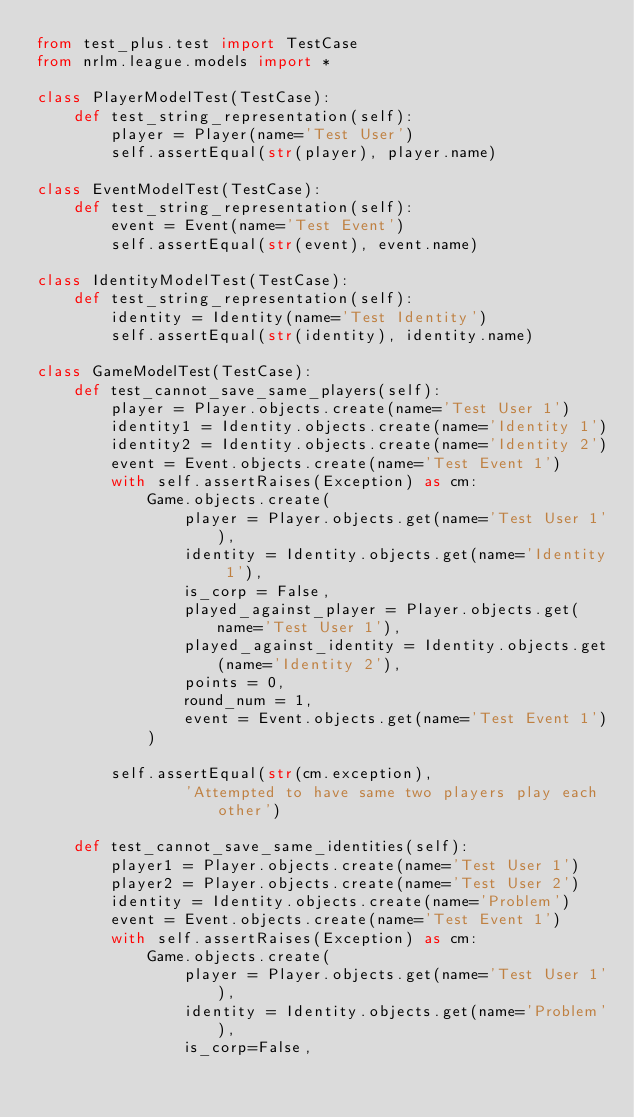Convert code to text. <code><loc_0><loc_0><loc_500><loc_500><_Python_>from test_plus.test import TestCase
from nrlm.league.models import *

class PlayerModelTest(TestCase):
    def test_string_representation(self):
        player = Player(name='Test User')
        self.assertEqual(str(player), player.name)

class EventModelTest(TestCase):
    def test_string_representation(self):
        event = Event(name='Test Event')
        self.assertEqual(str(event), event.name)

class IdentityModelTest(TestCase):
    def test_string_representation(self):
        identity = Identity(name='Test Identity')
        self.assertEqual(str(identity), identity.name)

class GameModelTest(TestCase):
    def test_cannot_save_same_players(self):
        player = Player.objects.create(name='Test User 1')
        identity1 = Identity.objects.create(name='Identity 1')
        identity2 = Identity.objects.create(name='Identity 2')
        event = Event.objects.create(name='Test Event 1')
        with self.assertRaises(Exception) as cm:
            Game.objects.create(
                player = Player.objects.get(name='Test User 1'),
                identity = Identity.objects.get(name='Identity 1'),
                is_corp = False,
                played_against_player = Player.objects.get(name='Test User 1'),
                played_against_identity = Identity.objects.get(name='Identity 2'),
                points = 0,
                round_num = 1,
                event = Event.objects.get(name='Test Event 1')
            )

        self.assertEqual(str(cm.exception), 
                'Attempted to have same two players play each other')

    def test_cannot_save_same_identities(self):
        player1 = Player.objects.create(name='Test User 1')
        player2 = Player.objects.create(name='Test User 2')
        identity = Identity.objects.create(name='Problem')
        event = Event.objects.create(name='Test Event 1')
        with self.assertRaises(Exception) as cm:
            Game.objects.create(
                player = Player.objects.get(name='Test User 1'),
                identity = Identity.objects.get(name='Problem'),
                is_corp=False,</code> 